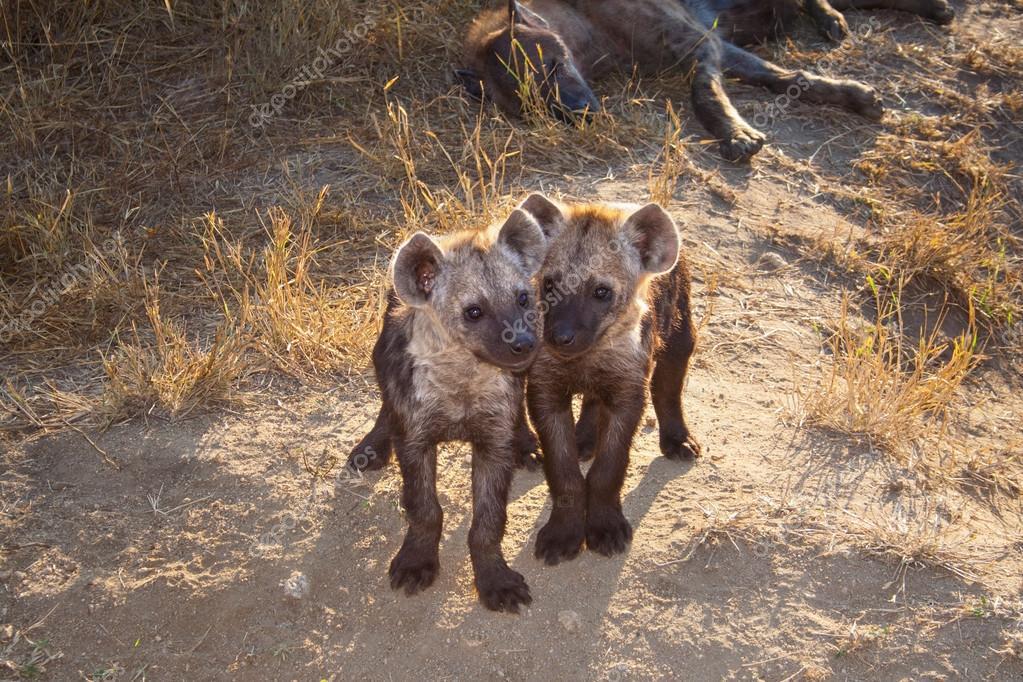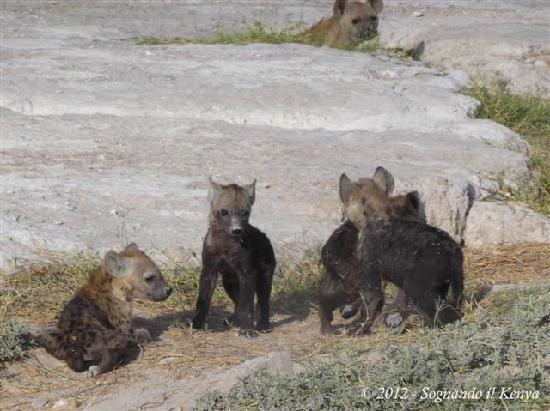The first image is the image on the left, the second image is the image on the right. Considering the images on both sides, is "There are exactly four hyenas." valid? Answer yes or no. No. 